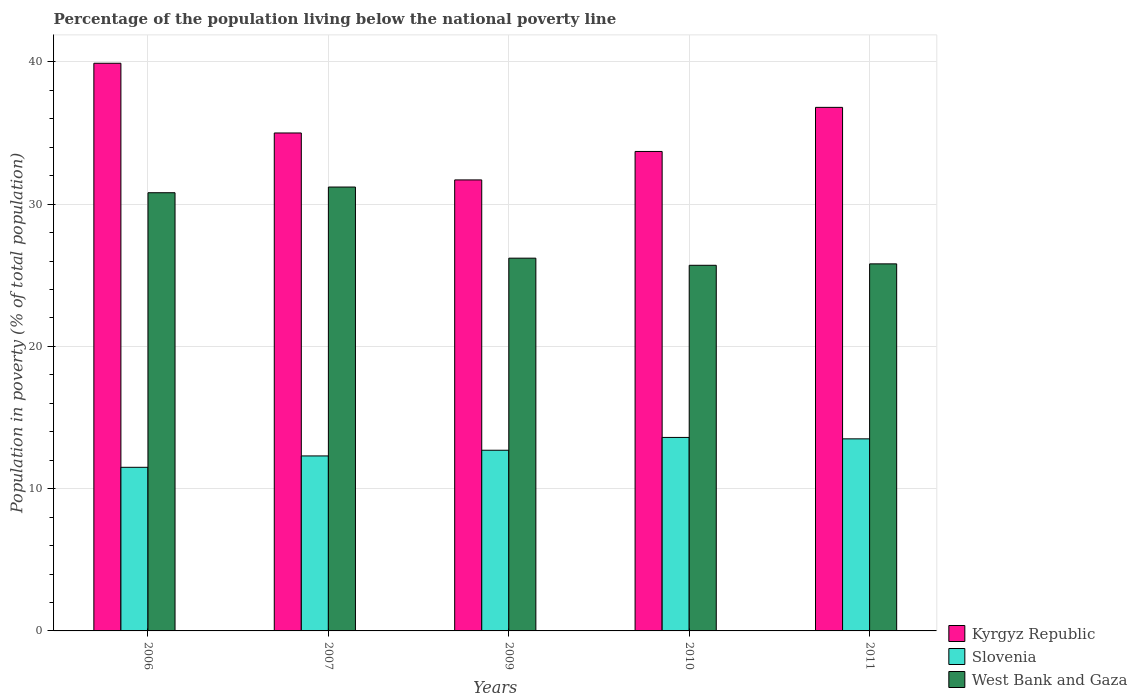How many different coloured bars are there?
Your answer should be compact. 3. How many groups of bars are there?
Ensure brevity in your answer.  5. How many bars are there on the 3rd tick from the left?
Ensure brevity in your answer.  3. How many bars are there on the 5th tick from the right?
Your response must be concise. 3. In how many cases, is the number of bars for a given year not equal to the number of legend labels?
Provide a succinct answer. 0. What is the percentage of the population living below the national poverty line in West Bank and Gaza in 2006?
Your response must be concise. 30.8. Across all years, what is the maximum percentage of the population living below the national poverty line in Slovenia?
Offer a terse response. 13.6. In which year was the percentage of the population living below the national poverty line in Slovenia maximum?
Your answer should be very brief. 2010. In which year was the percentage of the population living below the national poverty line in Kyrgyz Republic minimum?
Your answer should be compact. 2009. What is the total percentage of the population living below the national poverty line in Kyrgyz Republic in the graph?
Ensure brevity in your answer.  177.1. What is the difference between the percentage of the population living below the national poverty line in Kyrgyz Republic in 2007 and that in 2011?
Provide a short and direct response. -1.8. What is the difference between the percentage of the population living below the national poverty line in West Bank and Gaza in 2007 and the percentage of the population living below the national poverty line in Slovenia in 2009?
Offer a terse response. 18.5. What is the average percentage of the population living below the national poverty line in West Bank and Gaza per year?
Your response must be concise. 27.94. In the year 2010, what is the difference between the percentage of the population living below the national poverty line in West Bank and Gaza and percentage of the population living below the national poverty line in Kyrgyz Republic?
Provide a succinct answer. -8. In how many years, is the percentage of the population living below the national poverty line in Slovenia greater than 16 %?
Make the answer very short. 0. What is the ratio of the percentage of the population living below the national poverty line in West Bank and Gaza in 2006 to that in 2011?
Ensure brevity in your answer.  1.19. What is the difference between the highest and the second highest percentage of the population living below the national poverty line in West Bank and Gaza?
Provide a succinct answer. 0.4. What is the difference between the highest and the lowest percentage of the population living below the national poverty line in Slovenia?
Your answer should be compact. 2.1. In how many years, is the percentage of the population living below the national poverty line in West Bank and Gaza greater than the average percentage of the population living below the national poverty line in West Bank and Gaza taken over all years?
Provide a succinct answer. 2. What does the 2nd bar from the left in 2009 represents?
Ensure brevity in your answer.  Slovenia. What does the 1st bar from the right in 2011 represents?
Keep it short and to the point. West Bank and Gaza. Is it the case that in every year, the sum of the percentage of the population living below the national poverty line in West Bank and Gaza and percentage of the population living below the national poverty line in Slovenia is greater than the percentage of the population living below the national poverty line in Kyrgyz Republic?
Your answer should be compact. Yes. How many years are there in the graph?
Offer a very short reply. 5. What is the difference between two consecutive major ticks on the Y-axis?
Offer a terse response. 10. Does the graph contain any zero values?
Your response must be concise. No. Does the graph contain grids?
Your response must be concise. Yes. Where does the legend appear in the graph?
Your answer should be compact. Bottom right. How are the legend labels stacked?
Give a very brief answer. Vertical. What is the title of the graph?
Your answer should be very brief. Percentage of the population living below the national poverty line. What is the label or title of the X-axis?
Provide a short and direct response. Years. What is the label or title of the Y-axis?
Give a very brief answer. Population in poverty (% of total population). What is the Population in poverty (% of total population) of Kyrgyz Republic in 2006?
Make the answer very short. 39.9. What is the Population in poverty (% of total population) of Slovenia in 2006?
Your answer should be very brief. 11.5. What is the Population in poverty (% of total population) in West Bank and Gaza in 2006?
Keep it short and to the point. 30.8. What is the Population in poverty (% of total population) of West Bank and Gaza in 2007?
Provide a succinct answer. 31.2. What is the Population in poverty (% of total population) in Kyrgyz Republic in 2009?
Your answer should be very brief. 31.7. What is the Population in poverty (% of total population) in West Bank and Gaza in 2009?
Make the answer very short. 26.2. What is the Population in poverty (% of total population) in Kyrgyz Republic in 2010?
Provide a short and direct response. 33.7. What is the Population in poverty (% of total population) in Slovenia in 2010?
Your answer should be compact. 13.6. What is the Population in poverty (% of total population) in West Bank and Gaza in 2010?
Offer a very short reply. 25.7. What is the Population in poverty (% of total population) in Kyrgyz Republic in 2011?
Ensure brevity in your answer.  36.8. What is the Population in poverty (% of total population) of West Bank and Gaza in 2011?
Make the answer very short. 25.8. Across all years, what is the maximum Population in poverty (% of total population) of Kyrgyz Republic?
Your response must be concise. 39.9. Across all years, what is the maximum Population in poverty (% of total population) in Slovenia?
Provide a succinct answer. 13.6. Across all years, what is the maximum Population in poverty (% of total population) in West Bank and Gaza?
Your answer should be very brief. 31.2. Across all years, what is the minimum Population in poverty (% of total population) in Kyrgyz Republic?
Make the answer very short. 31.7. Across all years, what is the minimum Population in poverty (% of total population) of Slovenia?
Your answer should be very brief. 11.5. Across all years, what is the minimum Population in poverty (% of total population) in West Bank and Gaza?
Offer a terse response. 25.7. What is the total Population in poverty (% of total population) in Kyrgyz Republic in the graph?
Keep it short and to the point. 177.1. What is the total Population in poverty (% of total population) of Slovenia in the graph?
Offer a terse response. 63.6. What is the total Population in poverty (% of total population) in West Bank and Gaza in the graph?
Give a very brief answer. 139.7. What is the difference between the Population in poverty (% of total population) in Slovenia in 2006 and that in 2007?
Keep it short and to the point. -0.8. What is the difference between the Population in poverty (% of total population) of West Bank and Gaza in 2006 and that in 2007?
Make the answer very short. -0.4. What is the difference between the Population in poverty (% of total population) of Kyrgyz Republic in 2006 and that in 2009?
Your answer should be very brief. 8.2. What is the difference between the Population in poverty (% of total population) in Slovenia in 2006 and that in 2009?
Ensure brevity in your answer.  -1.2. What is the difference between the Population in poverty (% of total population) in West Bank and Gaza in 2006 and that in 2009?
Provide a succinct answer. 4.6. What is the difference between the Population in poverty (% of total population) in Kyrgyz Republic in 2006 and that in 2010?
Provide a succinct answer. 6.2. What is the difference between the Population in poverty (% of total population) of West Bank and Gaza in 2006 and that in 2010?
Offer a very short reply. 5.1. What is the difference between the Population in poverty (% of total population) in Slovenia in 2006 and that in 2011?
Your answer should be very brief. -2. What is the difference between the Population in poverty (% of total population) of Kyrgyz Republic in 2007 and that in 2009?
Give a very brief answer. 3.3. What is the difference between the Population in poverty (% of total population) in Slovenia in 2007 and that in 2009?
Give a very brief answer. -0.4. What is the difference between the Population in poverty (% of total population) in West Bank and Gaza in 2007 and that in 2009?
Your response must be concise. 5. What is the difference between the Population in poverty (% of total population) in Kyrgyz Republic in 2007 and that in 2011?
Your response must be concise. -1.8. What is the difference between the Population in poverty (% of total population) of West Bank and Gaza in 2007 and that in 2011?
Provide a succinct answer. 5.4. What is the difference between the Population in poverty (% of total population) in Kyrgyz Republic in 2009 and that in 2010?
Offer a very short reply. -2. What is the difference between the Population in poverty (% of total population) of Kyrgyz Republic in 2009 and that in 2011?
Provide a succinct answer. -5.1. What is the difference between the Population in poverty (% of total population) of Slovenia in 2010 and that in 2011?
Offer a terse response. 0.1. What is the difference between the Population in poverty (% of total population) of Kyrgyz Republic in 2006 and the Population in poverty (% of total population) of Slovenia in 2007?
Offer a very short reply. 27.6. What is the difference between the Population in poverty (% of total population) in Slovenia in 2006 and the Population in poverty (% of total population) in West Bank and Gaza in 2007?
Give a very brief answer. -19.7. What is the difference between the Population in poverty (% of total population) in Kyrgyz Republic in 2006 and the Population in poverty (% of total population) in Slovenia in 2009?
Make the answer very short. 27.2. What is the difference between the Population in poverty (% of total population) of Kyrgyz Republic in 2006 and the Population in poverty (% of total population) of West Bank and Gaza in 2009?
Give a very brief answer. 13.7. What is the difference between the Population in poverty (% of total population) of Slovenia in 2006 and the Population in poverty (% of total population) of West Bank and Gaza in 2009?
Your answer should be very brief. -14.7. What is the difference between the Population in poverty (% of total population) in Kyrgyz Republic in 2006 and the Population in poverty (% of total population) in Slovenia in 2010?
Provide a short and direct response. 26.3. What is the difference between the Population in poverty (% of total population) in Kyrgyz Republic in 2006 and the Population in poverty (% of total population) in Slovenia in 2011?
Provide a succinct answer. 26.4. What is the difference between the Population in poverty (% of total population) in Slovenia in 2006 and the Population in poverty (% of total population) in West Bank and Gaza in 2011?
Your answer should be compact. -14.3. What is the difference between the Population in poverty (% of total population) of Kyrgyz Republic in 2007 and the Population in poverty (% of total population) of Slovenia in 2009?
Keep it short and to the point. 22.3. What is the difference between the Population in poverty (% of total population) in Kyrgyz Republic in 2007 and the Population in poverty (% of total population) in West Bank and Gaza in 2009?
Provide a succinct answer. 8.8. What is the difference between the Population in poverty (% of total population) in Slovenia in 2007 and the Population in poverty (% of total population) in West Bank and Gaza in 2009?
Your response must be concise. -13.9. What is the difference between the Population in poverty (% of total population) of Kyrgyz Republic in 2007 and the Population in poverty (% of total population) of Slovenia in 2010?
Give a very brief answer. 21.4. What is the difference between the Population in poverty (% of total population) of Kyrgyz Republic in 2007 and the Population in poverty (% of total population) of West Bank and Gaza in 2010?
Keep it short and to the point. 9.3. What is the difference between the Population in poverty (% of total population) of Kyrgyz Republic in 2007 and the Population in poverty (% of total population) of Slovenia in 2011?
Offer a terse response. 21.5. What is the difference between the Population in poverty (% of total population) in Kyrgyz Republic in 2009 and the Population in poverty (% of total population) in Slovenia in 2011?
Keep it short and to the point. 18.2. What is the difference between the Population in poverty (% of total population) in Slovenia in 2009 and the Population in poverty (% of total population) in West Bank and Gaza in 2011?
Your answer should be compact. -13.1. What is the difference between the Population in poverty (% of total population) of Kyrgyz Republic in 2010 and the Population in poverty (% of total population) of Slovenia in 2011?
Your response must be concise. 20.2. What is the difference between the Population in poverty (% of total population) in Slovenia in 2010 and the Population in poverty (% of total population) in West Bank and Gaza in 2011?
Provide a short and direct response. -12.2. What is the average Population in poverty (% of total population) in Kyrgyz Republic per year?
Provide a succinct answer. 35.42. What is the average Population in poverty (% of total population) in Slovenia per year?
Your answer should be very brief. 12.72. What is the average Population in poverty (% of total population) of West Bank and Gaza per year?
Provide a succinct answer. 27.94. In the year 2006, what is the difference between the Population in poverty (% of total population) in Kyrgyz Republic and Population in poverty (% of total population) in Slovenia?
Ensure brevity in your answer.  28.4. In the year 2006, what is the difference between the Population in poverty (% of total population) in Kyrgyz Republic and Population in poverty (% of total population) in West Bank and Gaza?
Your answer should be very brief. 9.1. In the year 2006, what is the difference between the Population in poverty (% of total population) of Slovenia and Population in poverty (% of total population) of West Bank and Gaza?
Keep it short and to the point. -19.3. In the year 2007, what is the difference between the Population in poverty (% of total population) in Kyrgyz Republic and Population in poverty (% of total population) in Slovenia?
Give a very brief answer. 22.7. In the year 2007, what is the difference between the Population in poverty (% of total population) in Slovenia and Population in poverty (% of total population) in West Bank and Gaza?
Your answer should be compact. -18.9. In the year 2009, what is the difference between the Population in poverty (% of total population) of Kyrgyz Republic and Population in poverty (% of total population) of Slovenia?
Make the answer very short. 19. In the year 2009, what is the difference between the Population in poverty (% of total population) in Kyrgyz Republic and Population in poverty (% of total population) in West Bank and Gaza?
Keep it short and to the point. 5.5. In the year 2009, what is the difference between the Population in poverty (% of total population) of Slovenia and Population in poverty (% of total population) of West Bank and Gaza?
Your answer should be very brief. -13.5. In the year 2010, what is the difference between the Population in poverty (% of total population) of Kyrgyz Republic and Population in poverty (% of total population) of Slovenia?
Provide a short and direct response. 20.1. In the year 2011, what is the difference between the Population in poverty (% of total population) in Kyrgyz Republic and Population in poverty (% of total population) in Slovenia?
Give a very brief answer. 23.3. In the year 2011, what is the difference between the Population in poverty (% of total population) of Slovenia and Population in poverty (% of total population) of West Bank and Gaza?
Your answer should be very brief. -12.3. What is the ratio of the Population in poverty (% of total population) in Kyrgyz Republic in 2006 to that in 2007?
Make the answer very short. 1.14. What is the ratio of the Population in poverty (% of total population) of Slovenia in 2006 to that in 2007?
Your response must be concise. 0.94. What is the ratio of the Population in poverty (% of total population) of West Bank and Gaza in 2006 to that in 2007?
Ensure brevity in your answer.  0.99. What is the ratio of the Population in poverty (% of total population) of Kyrgyz Republic in 2006 to that in 2009?
Your answer should be very brief. 1.26. What is the ratio of the Population in poverty (% of total population) in Slovenia in 2006 to that in 2009?
Give a very brief answer. 0.91. What is the ratio of the Population in poverty (% of total population) in West Bank and Gaza in 2006 to that in 2009?
Provide a short and direct response. 1.18. What is the ratio of the Population in poverty (% of total population) of Kyrgyz Republic in 2006 to that in 2010?
Offer a very short reply. 1.18. What is the ratio of the Population in poverty (% of total population) of Slovenia in 2006 to that in 2010?
Give a very brief answer. 0.85. What is the ratio of the Population in poverty (% of total population) in West Bank and Gaza in 2006 to that in 2010?
Give a very brief answer. 1.2. What is the ratio of the Population in poverty (% of total population) of Kyrgyz Republic in 2006 to that in 2011?
Your answer should be compact. 1.08. What is the ratio of the Population in poverty (% of total population) of Slovenia in 2006 to that in 2011?
Your answer should be very brief. 0.85. What is the ratio of the Population in poverty (% of total population) of West Bank and Gaza in 2006 to that in 2011?
Your answer should be very brief. 1.19. What is the ratio of the Population in poverty (% of total population) in Kyrgyz Republic in 2007 to that in 2009?
Provide a succinct answer. 1.1. What is the ratio of the Population in poverty (% of total population) of Slovenia in 2007 to that in 2009?
Your response must be concise. 0.97. What is the ratio of the Population in poverty (% of total population) in West Bank and Gaza in 2007 to that in 2009?
Offer a very short reply. 1.19. What is the ratio of the Population in poverty (% of total population) in Kyrgyz Republic in 2007 to that in 2010?
Provide a short and direct response. 1.04. What is the ratio of the Population in poverty (% of total population) of Slovenia in 2007 to that in 2010?
Ensure brevity in your answer.  0.9. What is the ratio of the Population in poverty (% of total population) of West Bank and Gaza in 2007 to that in 2010?
Ensure brevity in your answer.  1.21. What is the ratio of the Population in poverty (% of total population) of Kyrgyz Republic in 2007 to that in 2011?
Offer a terse response. 0.95. What is the ratio of the Population in poverty (% of total population) of Slovenia in 2007 to that in 2011?
Provide a short and direct response. 0.91. What is the ratio of the Population in poverty (% of total population) in West Bank and Gaza in 2007 to that in 2011?
Offer a very short reply. 1.21. What is the ratio of the Population in poverty (% of total population) of Kyrgyz Republic in 2009 to that in 2010?
Provide a short and direct response. 0.94. What is the ratio of the Population in poverty (% of total population) of Slovenia in 2009 to that in 2010?
Give a very brief answer. 0.93. What is the ratio of the Population in poverty (% of total population) of West Bank and Gaza in 2009 to that in 2010?
Give a very brief answer. 1.02. What is the ratio of the Population in poverty (% of total population) in Kyrgyz Republic in 2009 to that in 2011?
Provide a short and direct response. 0.86. What is the ratio of the Population in poverty (% of total population) of Slovenia in 2009 to that in 2011?
Provide a short and direct response. 0.94. What is the ratio of the Population in poverty (% of total population) in West Bank and Gaza in 2009 to that in 2011?
Ensure brevity in your answer.  1.02. What is the ratio of the Population in poverty (% of total population) in Kyrgyz Republic in 2010 to that in 2011?
Provide a succinct answer. 0.92. What is the ratio of the Population in poverty (% of total population) of Slovenia in 2010 to that in 2011?
Offer a very short reply. 1.01. What is the difference between the highest and the second highest Population in poverty (% of total population) in Slovenia?
Your response must be concise. 0.1. What is the difference between the highest and the second highest Population in poverty (% of total population) in West Bank and Gaza?
Ensure brevity in your answer.  0.4. What is the difference between the highest and the lowest Population in poverty (% of total population) of Slovenia?
Your answer should be very brief. 2.1. 